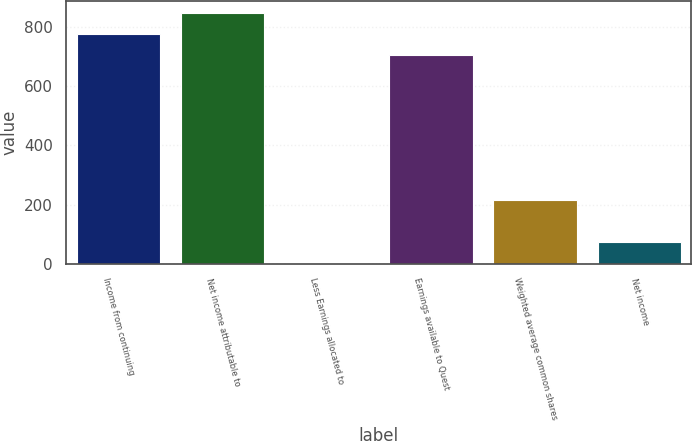<chart> <loc_0><loc_0><loc_500><loc_500><bar_chart><fcel>Income from continuing<fcel>Net income attributable to<fcel>Less Earnings allocated to<fcel>Earnings available to Quest<fcel>Weighted average common shares<fcel>Net income<nl><fcel>776.6<fcel>847.2<fcel>3<fcel>706<fcel>214.8<fcel>73.6<nl></chart> 